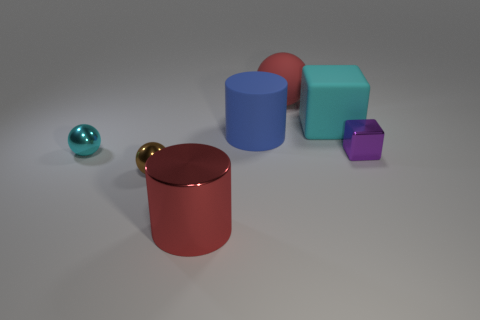What number of big red shiny objects are to the right of the shiny thing in front of the small brown object? There are no big red shiny objects to the right of the shiny object in front of the small brown object, as the only red shiny object in the image is a large cylinder which is placed centrally and not to the right of any other objects. 